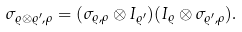Convert formula to latex. <formula><loc_0><loc_0><loc_500><loc_500>\sigma _ { \varrho \otimes \varrho ^ { \prime } , \rho } = ( \sigma _ { \varrho , \rho } \otimes I _ { \varrho ^ { \prime } } ) ( I _ { \varrho } \otimes \sigma _ { \varrho ^ { \prime } , \rho } ) .</formula> 